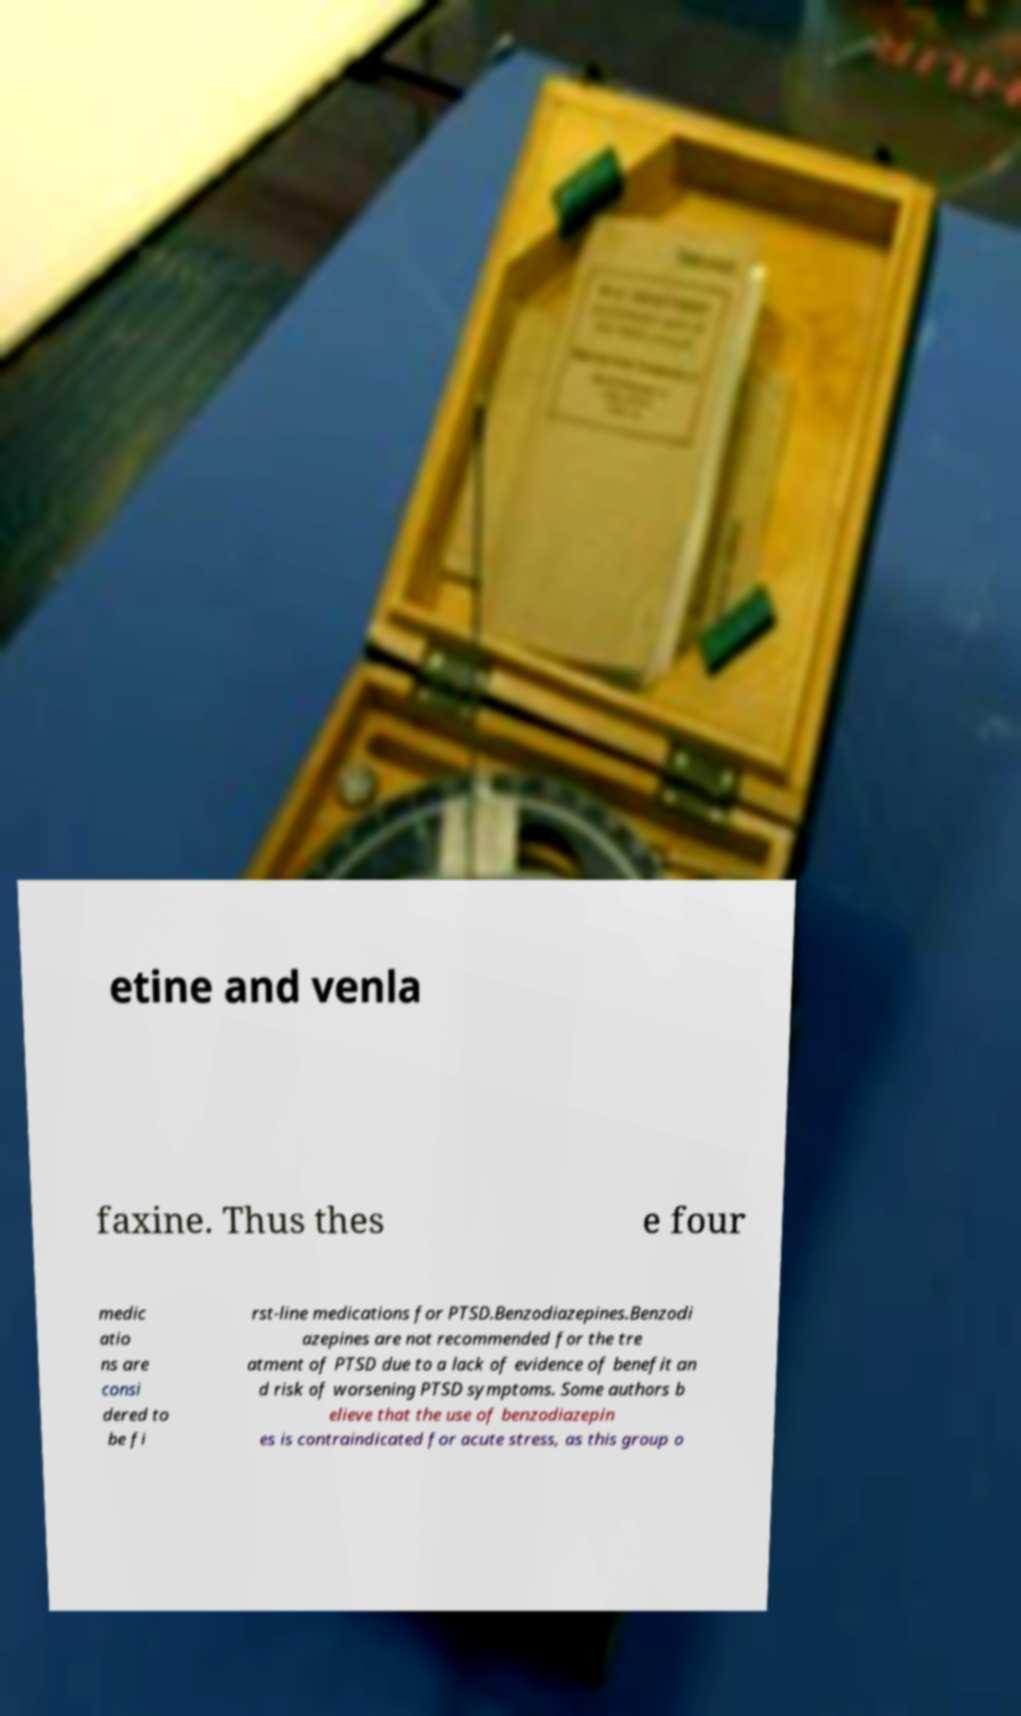Could you extract and type out the text from this image? etine and venla faxine. Thus thes e four medic atio ns are consi dered to be fi rst-line medications for PTSD.Benzodiazepines.Benzodi azepines are not recommended for the tre atment of PTSD due to a lack of evidence of benefit an d risk of worsening PTSD symptoms. Some authors b elieve that the use of benzodiazepin es is contraindicated for acute stress, as this group o 